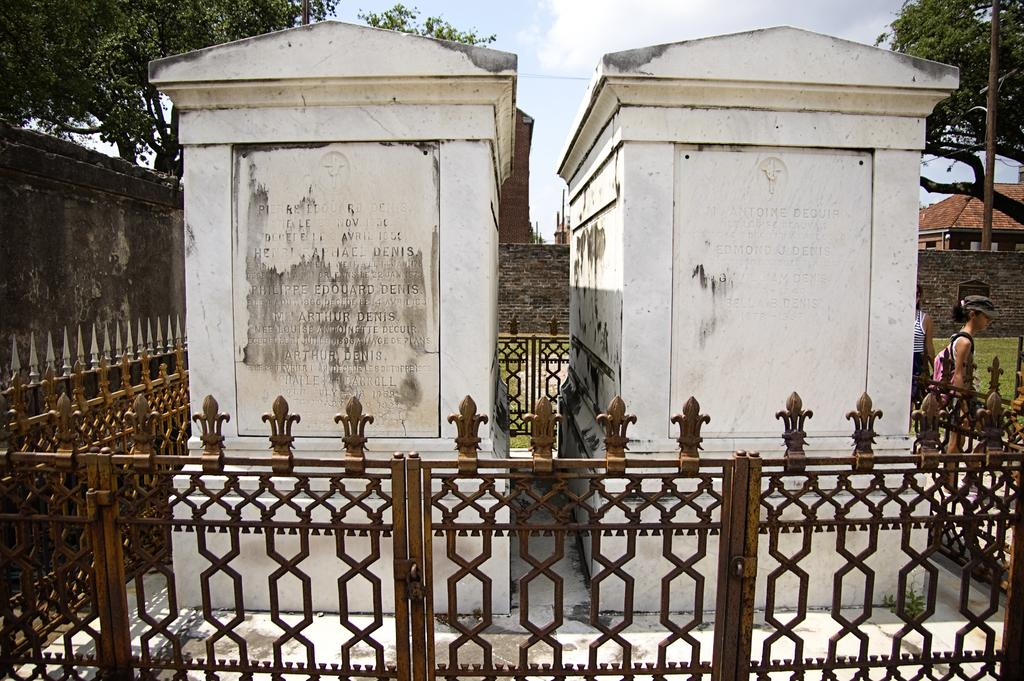What is the main subject of the image? The main subject of the image is the Saint Louis Cemetery. What is the purpose of the fence surrounding the cemetery? The fence is likely there to protect and secure the cemetery. Can you describe the people in the image? There are two persons in the right corner of the image. What can be seen in the background of the image? There are trees in the background of the image. How does the hospital compare to the cemetery in the image? There is no hospital present in the image, so it cannot be compared to the cemetery. How many trucks are visible in the image? There are no trucks visible in the image. 